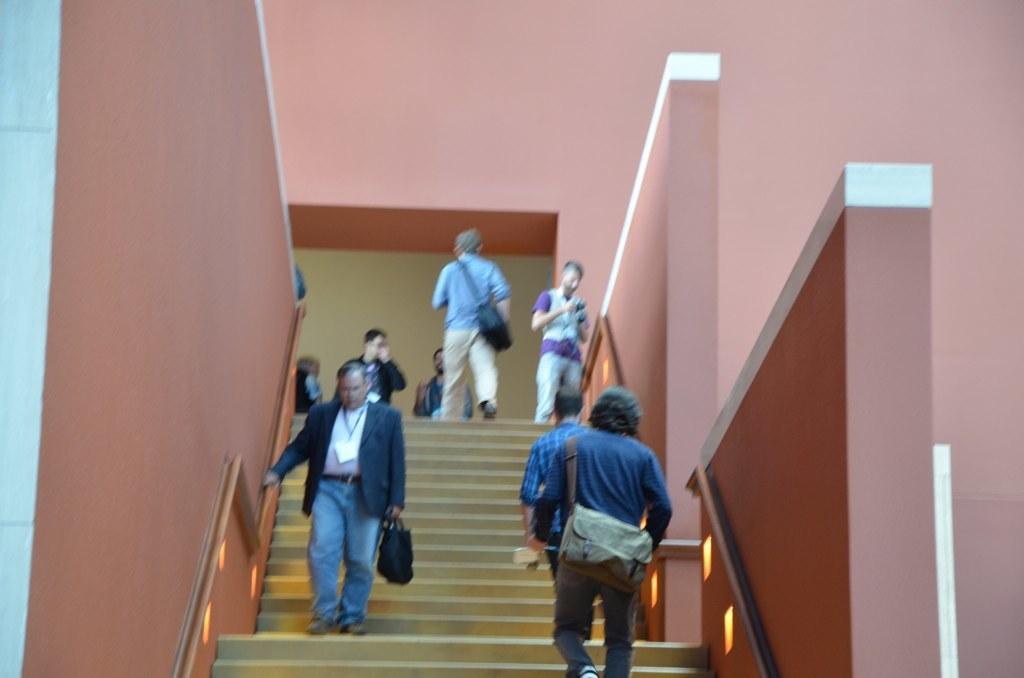Can you describe this image briefly? In the center of the image there are stairs and we can see people climbing stairs. In the background there is a wall. 